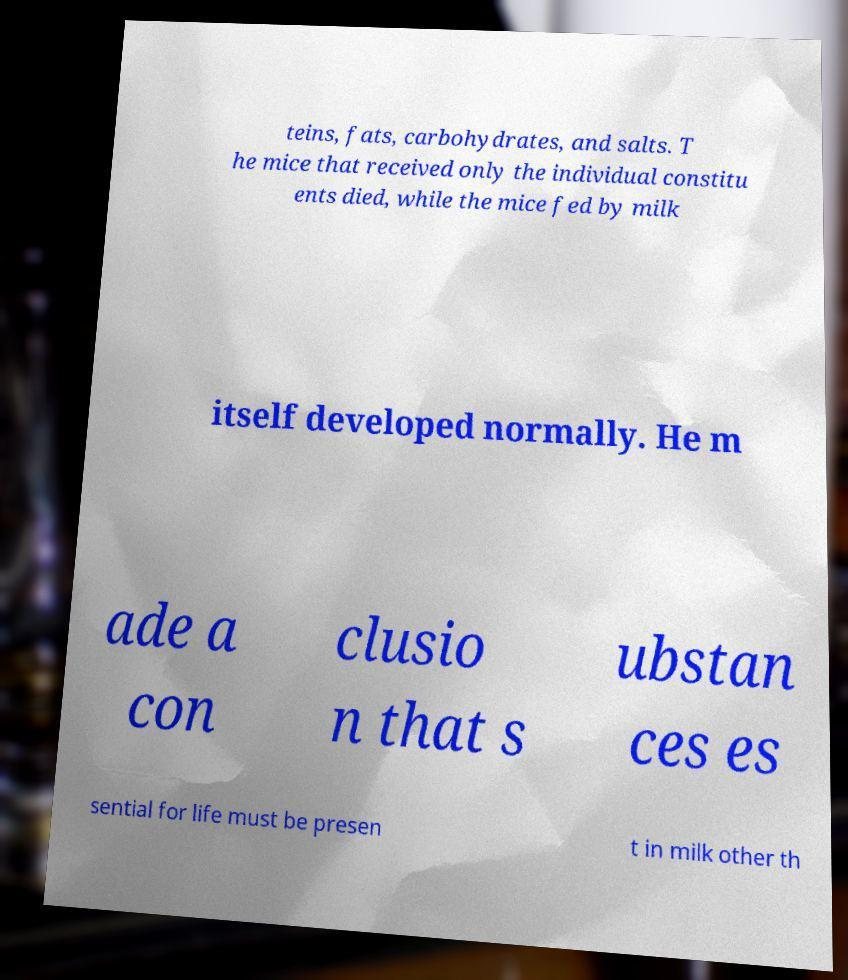Please identify and transcribe the text found in this image. teins, fats, carbohydrates, and salts. T he mice that received only the individual constitu ents died, while the mice fed by milk itself developed normally. He m ade a con clusio n that s ubstan ces es sential for life must be presen t in milk other th 